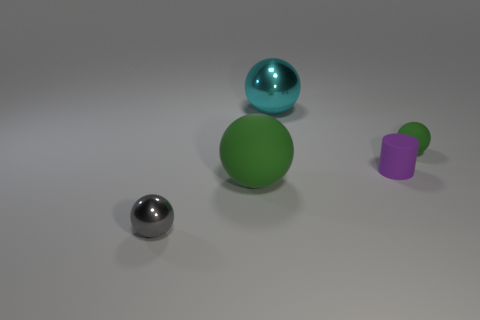Add 4 tiny rubber objects. How many objects exist? 9 Subtract all balls. How many objects are left? 1 Subtract all purple rubber cylinders. Subtract all tiny purple rubber cylinders. How many objects are left? 3 Add 1 gray metallic spheres. How many gray metallic spheres are left? 2 Add 4 large green spheres. How many large green spheres exist? 5 Subtract 1 gray spheres. How many objects are left? 4 